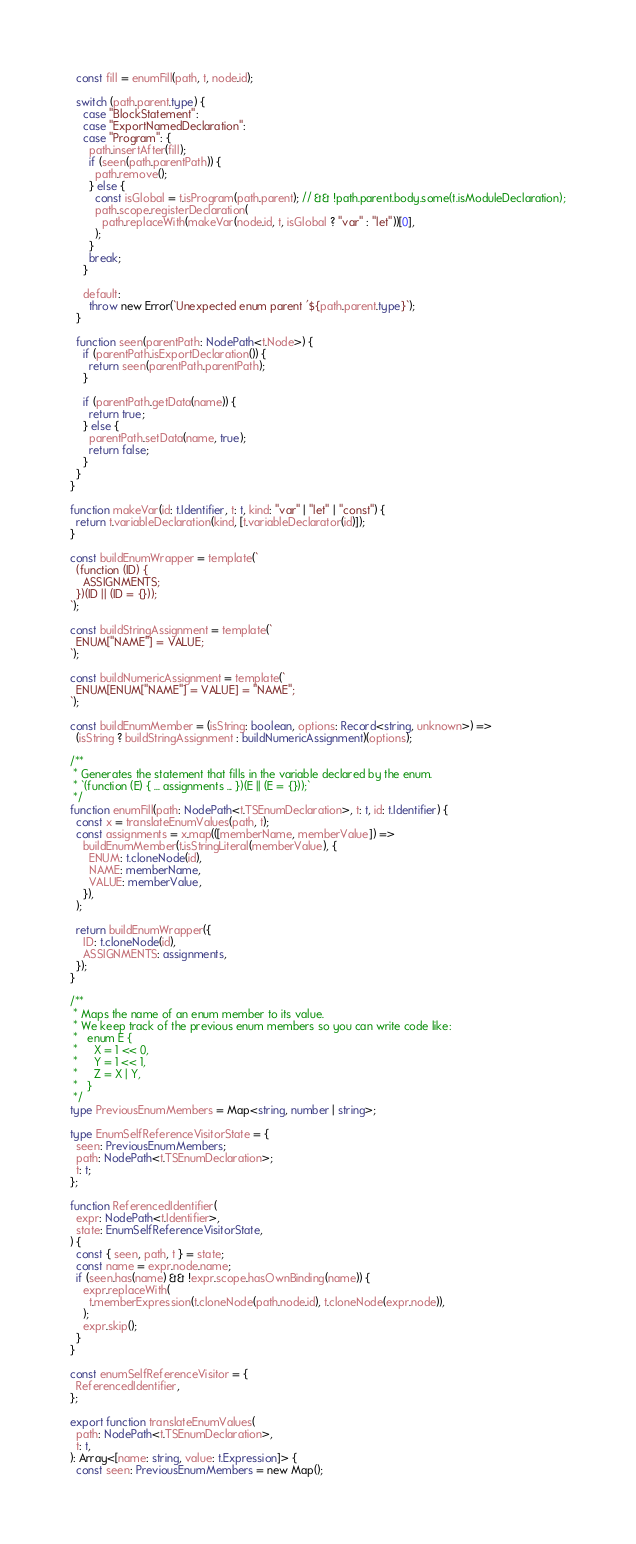Convert code to text. <code><loc_0><loc_0><loc_500><loc_500><_TypeScript_>  const fill = enumFill(path, t, node.id);

  switch (path.parent.type) {
    case "BlockStatement":
    case "ExportNamedDeclaration":
    case "Program": {
      path.insertAfter(fill);
      if (seen(path.parentPath)) {
        path.remove();
      } else {
        const isGlobal = t.isProgram(path.parent); // && !path.parent.body.some(t.isModuleDeclaration);
        path.scope.registerDeclaration(
          path.replaceWith(makeVar(node.id, t, isGlobal ? "var" : "let"))[0],
        );
      }
      break;
    }

    default:
      throw new Error(`Unexpected enum parent '${path.parent.type}`);
  }

  function seen(parentPath: NodePath<t.Node>) {
    if (parentPath.isExportDeclaration()) {
      return seen(parentPath.parentPath);
    }

    if (parentPath.getData(name)) {
      return true;
    } else {
      parentPath.setData(name, true);
      return false;
    }
  }
}

function makeVar(id: t.Identifier, t: t, kind: "var" | "let" | "const") {
  return t.variableDeclaration(kind, [t.variableDeclarator(id)]);
}

const buildEnumWrapper = template(`
  (function (ID) {
    ASSIGNMENTS;
  })(ID || (ID = {}));
`);

const buildStringAssignment = template(`
  ENUM["NAME"] = VALUE;
`);

const buildNumericAssignment = template(`
  ENUM[ENUM["NAME"] = VALUE] = "NAME";
`);

const buildEnumMember = (isString: boolean, options: Record<string, unknown>) =>
  (isString ? buildStringAssignment : buildNumericAssignment)(options);

/**
 * Generates the statement that fills in the variable declared by the enum.
 * `(function (E) { ... assignments ... })(E || (E = {}));`
 */
function enumFill(path: NodePath<t.TSEnumDeclaration>, t: t, id: t.Identifier) {
  const x = translateEnumValues(path, t);
  const assignments = x.map(([memberName, memberValue]) =>
    buildEnumMember(t.isStringLiteral(memberValue), {
      ENUM: t.cloneNode(id),
      NAME: memberName,
      VALUE: memberValue,
    }),
  );

  return buildEnumWrapper({
    ID: t.cloneNode(id),
    ASSIGNMENTS: assignments,
  });
}

/**
 * Maps the name of an enum member to its value.
 * We keep track of the previous enum members so you can write code like:
 *   enum E {
 *     X = 1 << 0,
 *     Y = 1 << 1,
 *     Z = X | Y,
 *   }
 */
type PreviousEnumMembers = Map<string, number | string>;

type EnumSelfReferenceVisitorState = {
  seen: PreviousEnumMembers;
  path: NodePath<t.TSEnumDeclaration>;
  t: t;
};

function ReferencedIdentifier(
  expr: NodePath<t.Identifier>,
  state: EnumSelfReferenceVisitorState,
) {
  const { seen, path, t } = state;
  const name = expr.node.name;
  if (seen.has(name) && !expr.scope.hasOwnBinding(name)) {
    expr.replaceWith(
      t.memberExpression(t.cloneNode(path.node.id), t.cloneNode(expr.node)),
    );
    expr.skip();
  }
}

const enumSelfReferenceVisitor = {
  ReferencedIdentifier,
};

export function translateEnumValues(
  path: NodePath<t.TSEnumDeclaration>,
  t: t,
): Array<[name: string, value: t.Expression]> {
  const seen: PreviousEnumMembers = new Map();</code> 